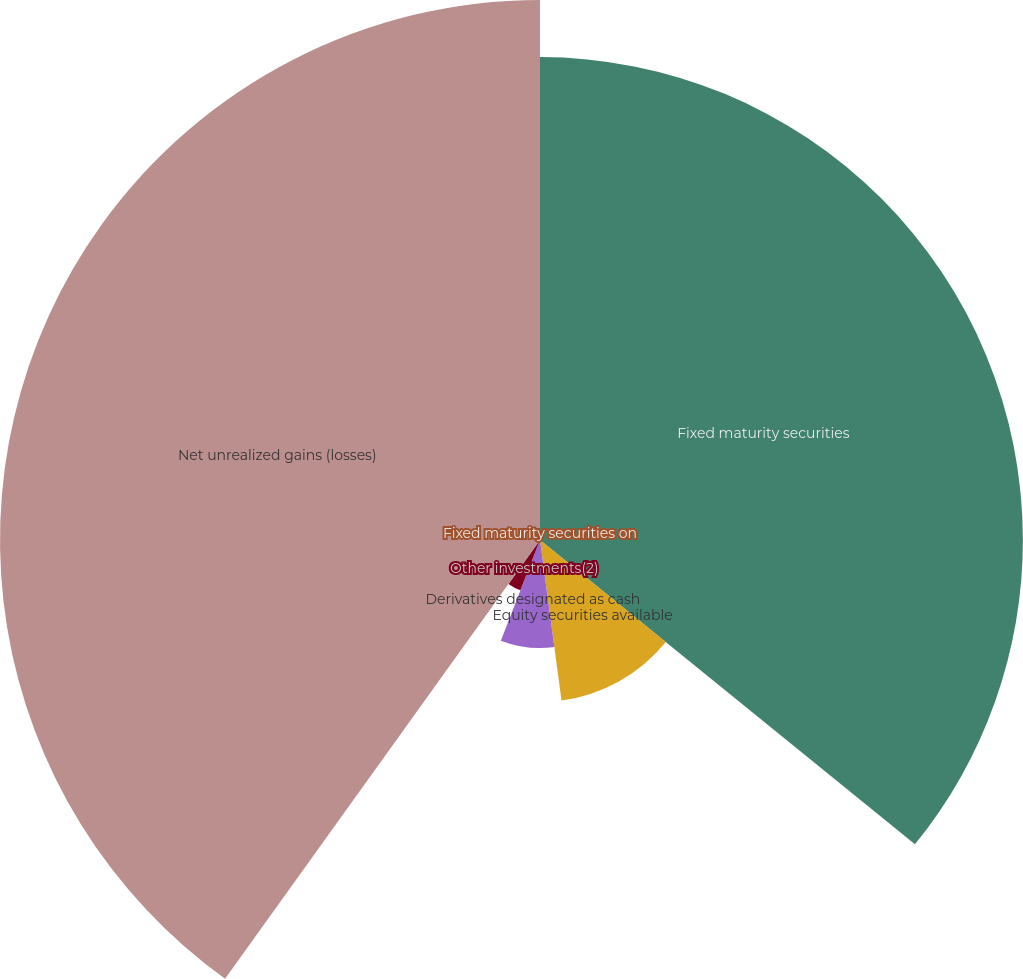<chart> <loc_0><loc_0><loc_500><loc_500><pie_chart><fcel>Fixed maturity securities on<fcel>Fixed maturity securities<fcel>Equity securities available<fcel>Derivatives designated as cash<fcel>Other investments(2)<fcel>Net unrealized gains (losses)<nl><fcel>0.0%<fcel>35.85%<fcel>12.03%<fcel>8.02%<fcel>4.01%<fcel>40.09%<nl></chart> 